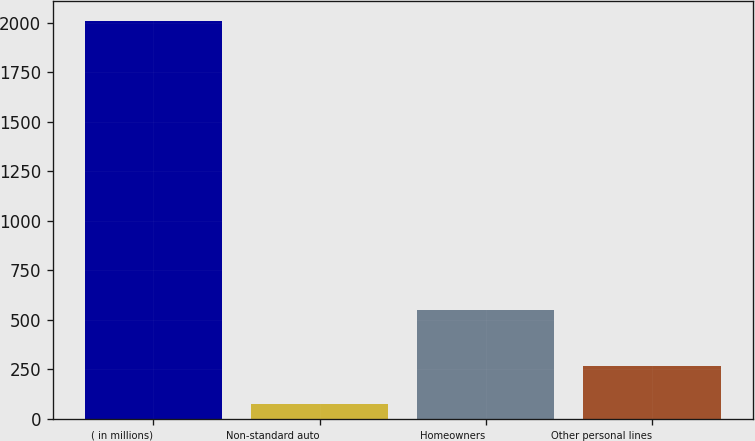Convert chart. <chart><loc_0><loc_0><loc_500><loc_500><bar_chart><fcel>( in millions)<fcel>Non-standard auto<fcel>Homeowners<fcel>Other personal lines<nl><fcel>2007<fcel>76<fcel>551<fcel>269.1<nl></chart> 